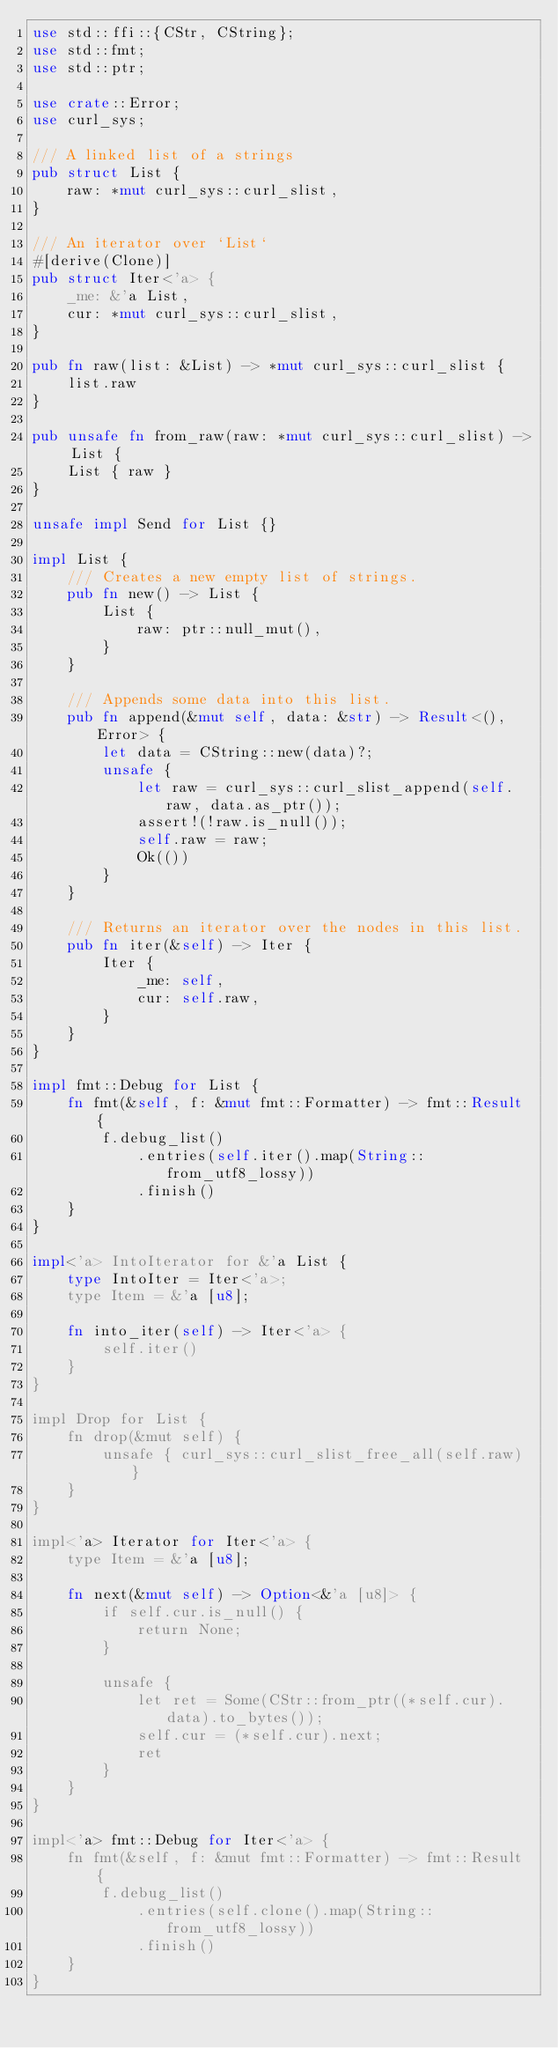Convert code to text. <code><loc_0><loc_0><loc_500><loc_500><_Rust_>use std::ffi::{CStr, CString};
use std::fmt;
use std::ptr;

use crate::Error;
use curl_sys;

/// A linked list of a strings
pub struct List {
    raw: *mut curl_sys::curl_slist,
}

/// An iterator over `List`
#[derive(Clone)]
pub struct Iter<'a> {
    _me: &'a List,
    cur: *mut curl_sys::curl_slist,
}

pub fn raw(list: &List) -> *mut curl_sys::curl_slist {
    list.raw
}

pub unsafe fn from_raw(raw: *mut curl_sys::curl_slist) -> List {
    List { raw }
}

unsafe impl Send for List {}

impl List {
    /// Creates a new empty list of strings.
    pub fn new() -> List {
        List {
            raw: ptr::null_mut(),
        }
    }

    /// Appends some data into this list.
    pub fn append(&mut self, data: &str) -> Result<(), Error> {
        let data = CString::new(data)?;
        unsafe {
            let raw = curl_sys::curl_slist_append(self.raw, data.as_ptr());
            assert!(!raw.is_null());
            self.raw = raw;
            Ok(())
        }
    }

    /// Returns an iterator over the nodes in this list.
    pub fn iter(&self) -> Iter {
        Iter {
            _me: self,
            cur: self.raw,
        }
    }
}

impl fmt::Debug for List {
    fn fmt(&self, f: &mut fmt::Formatter) -> fmt::Result {
        f.debug_list()
            .entries(self.iter().map(String::from_utf8_lossy))
            .finish()
    }
}

impl<'a> IntoIterator for &'a List {
    type IntoIter = Iter<'a>;
    type Item = &'a [u8];

    fn into_iter(self) -> Iter<'a> {
        self.iter()
    }
}

impl Drop for List {
    fn drop(&mut self) {
        unsafe { curl_sys::curl_slist_free_all(self.raw) }
    }
}

impl<'a> Iterator for Iter<'a> {
    type Item = &'a [u8];

    fn next(&mut self) -> Option<&'a [u8]> {
        if self.cur.is_null() {
            return None;
        }

        unsafe {
            let ret = Some(CStr::from_ptr((*self.cur).data).to_bytes());
            self.cur = (*self.cur).next;
            ret
        }
    }
}

impl<'a> fmt::Debug for Iter<'a> {
    fn fmt(&self, f: &mut fmt::Formatter) -> fmt::Result {
        f.debug_list()
            .entries(self.clone().map(String::from_utf8_lossy))
            .finish()
    }
}
</code> 